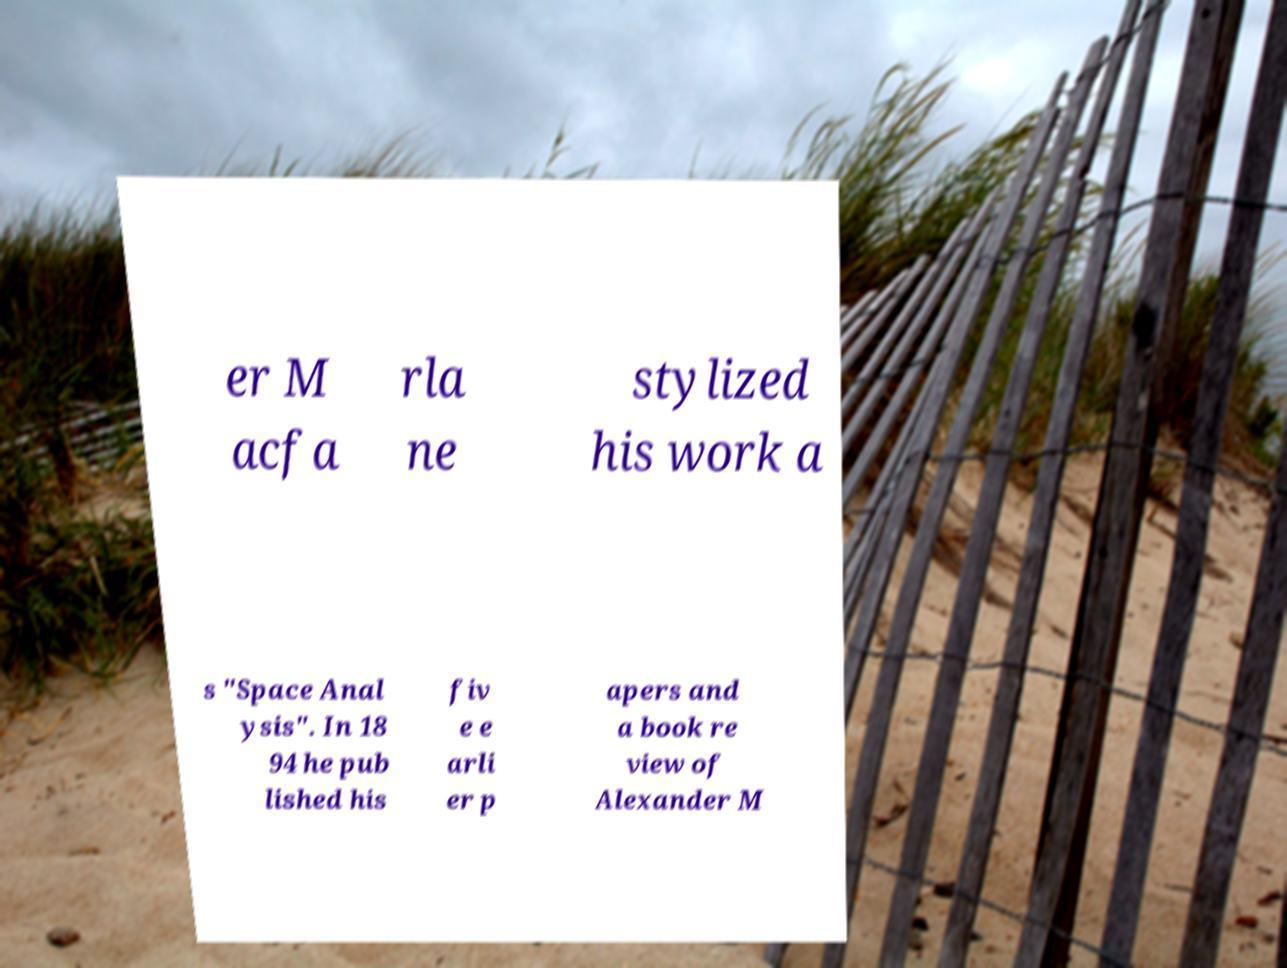Can you read and provide the text displayed in the image?This photo seems to have some interesting text. Can you extract and type it out for me? er M acfa rla ne stylized his work a s "Space Anal ysis". In 18 94 he pub lished his fiv e e arli er p apers and a book re view of Alexander M 